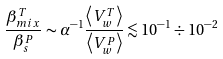Convert formula to latex. <formula><loc_0><loc_0><loc_500><loc_500>\frac { \beta _ { m i x } ^ { T } } { \beta _ { s } ^ { P } } \sim \alpha ^ { - 1 } \frac { \left \langle V _ { w } ^ { T } \right \rangle } { \left \langle V _ { w } ^ { P } \right \rangle } \lesssim 1 0 ^ { - 1 } \div 1 0 ^ { - 2 }</formula> 